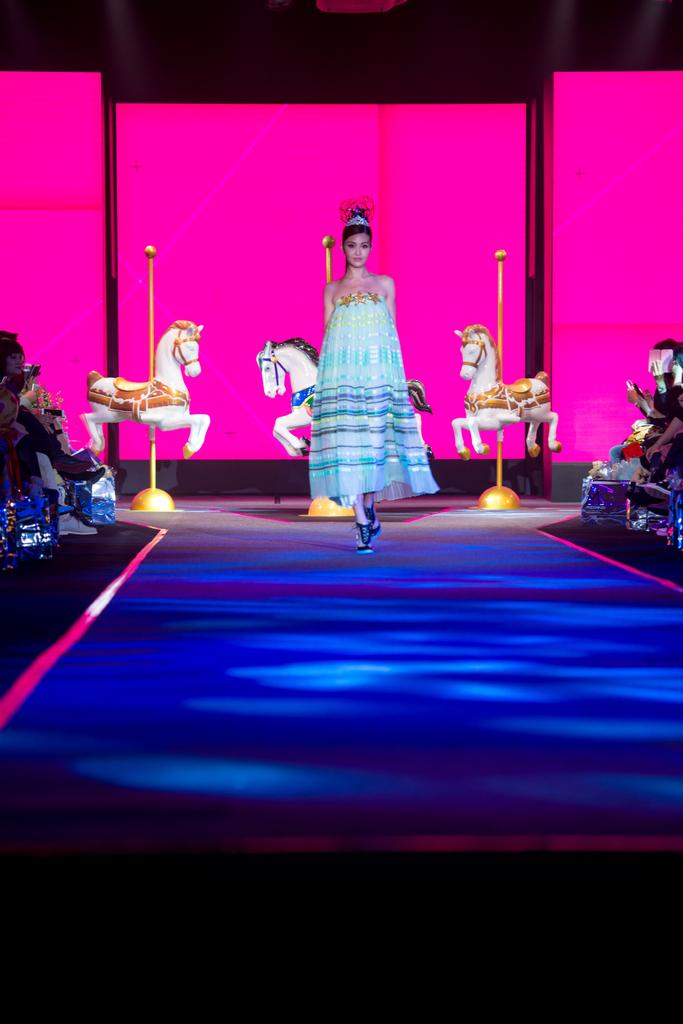Who is the main subject in the image? There is a woman in the image. What is the woman doing in the image? The woman is walking on the floor. What can be seen in the background of the image? There are toy horses and people in the background of the image. Is there a stream running through the room in the image? No, there is no stream visible in the image. 